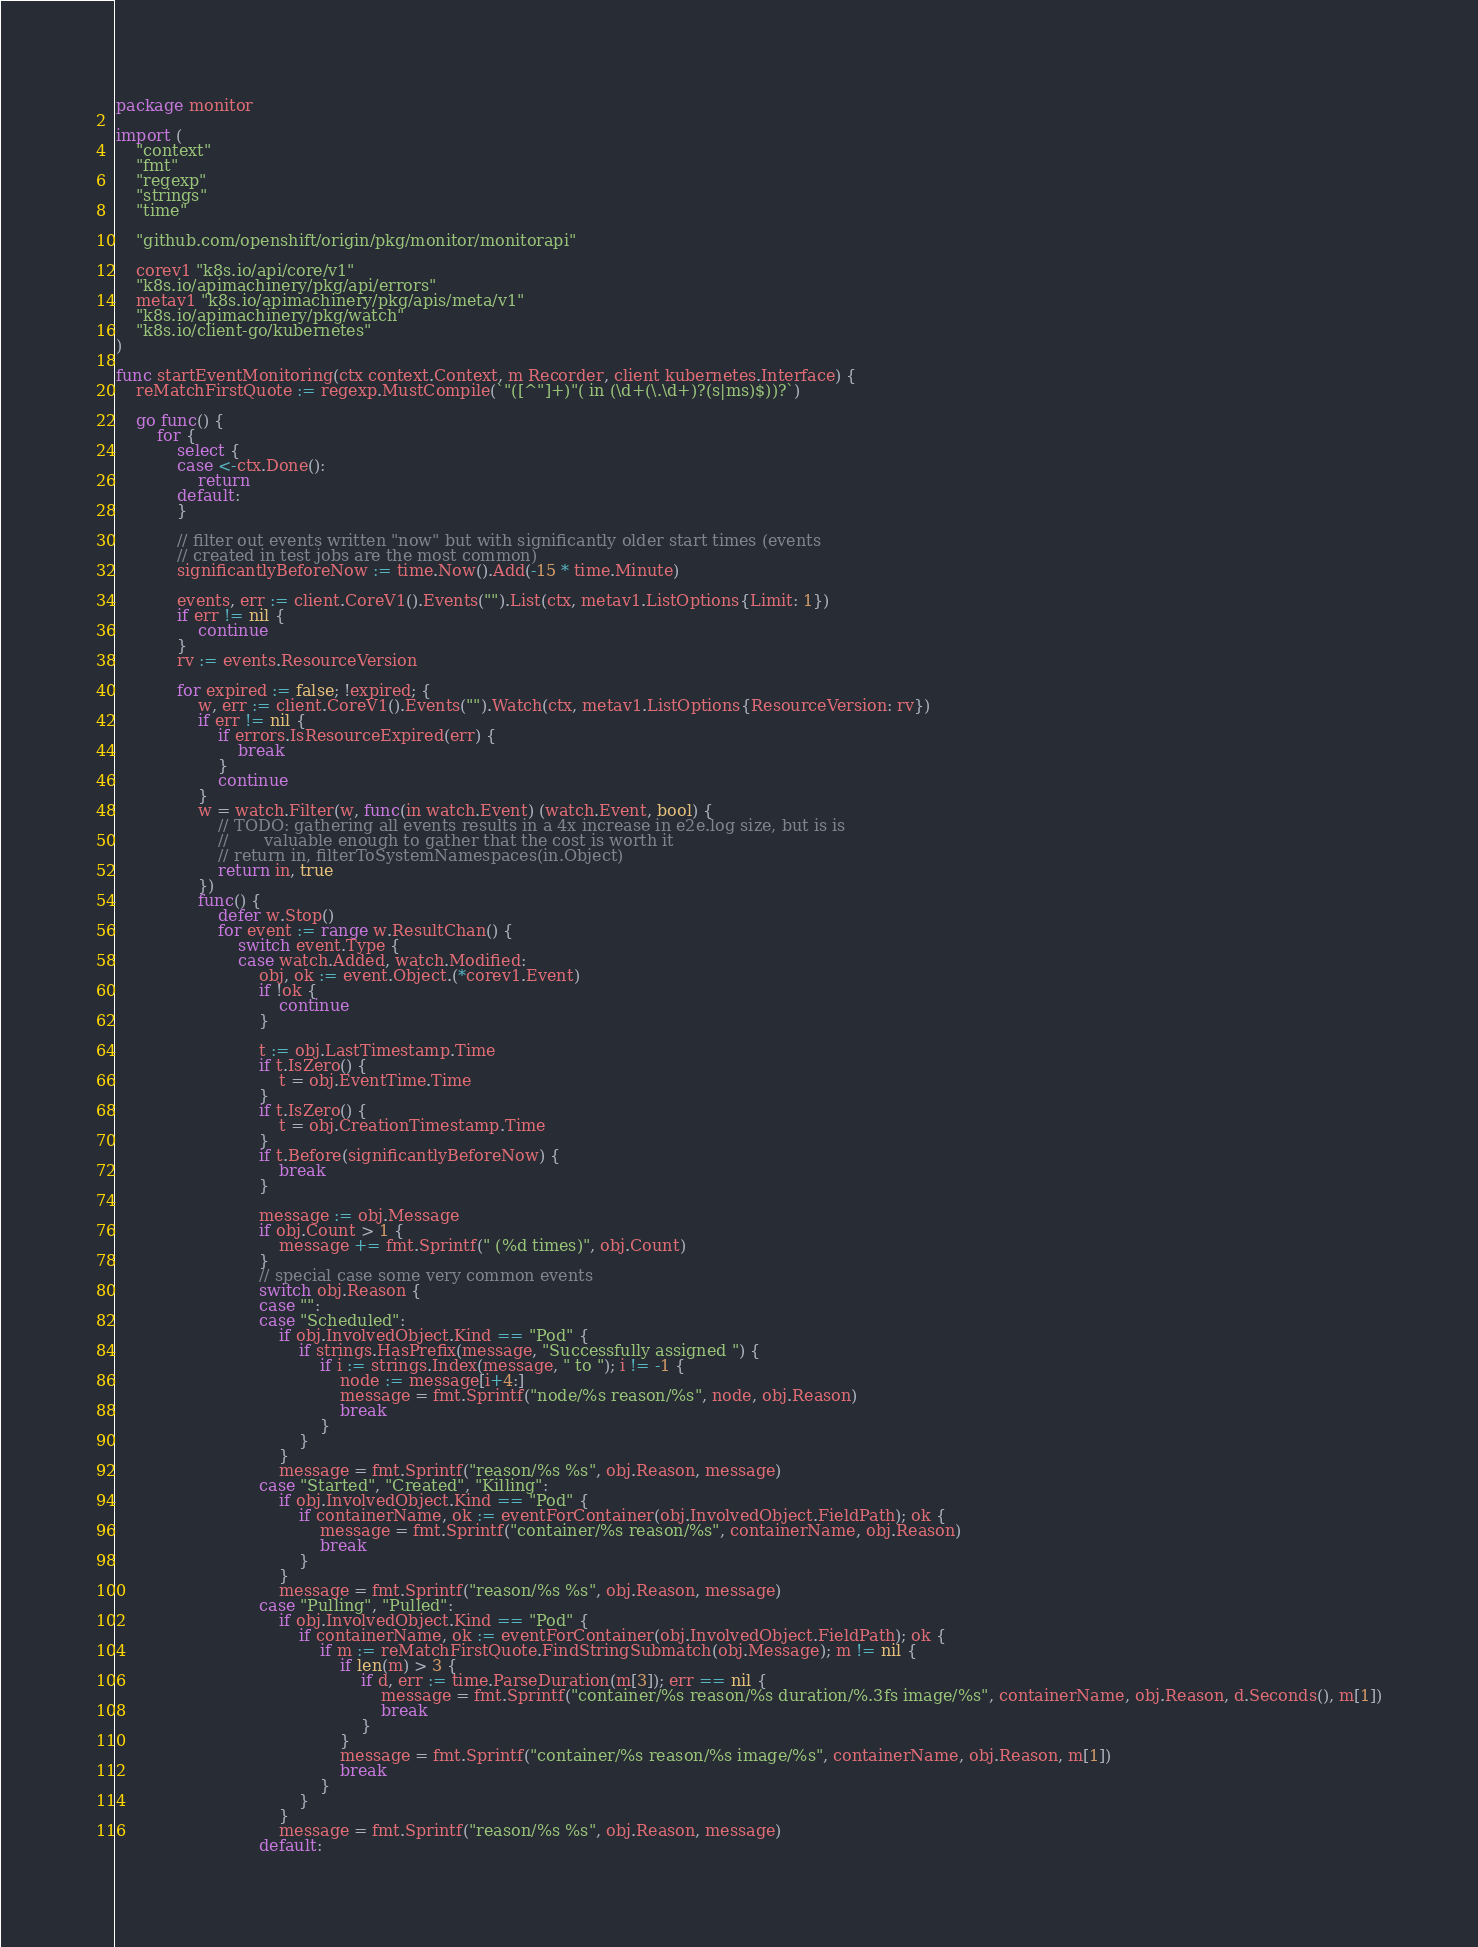Convert code to text. <code><loc_0><loc_0><loc_500><loc_500><_Go_>package monitor

import (
	"context"
	"fmt"
	"regexp"
	"strings"
	"time"

	"github.com/openshift/origin/pkg/monitor/monitorapi"

	corev1 "k8s.io/api/core/v1"
	"k8s.io/apimachinery/pkg/api/errors"
	metav1 "k8s.io/apimachinery/pkg/apis/meta/v1"
	"k8s.io/apimachinery/pkg/watch"
	"k8s.io/client-go/kubernetes"
)

func startEventMonitoring(ctx context.Context, m Recorder, client kubernetes.Interface) {
	reMatchFirstQuote := regexp.MustCompile(`"([^"]+)"( in (\d+(\.\d+)?(s|ms)$))?`)

	go func() {
		for {
			select {
			case <-ctx.Done():
				return
			default:
			}

			// filter out events written "now" but with significantly older start times (events
			// created in test jobs are the most common)
			significantlyBeforeNow := time.Now().Add(-15 * time.Minute)

			events, err := client.CoreV1().Events("").List(ctx, metav1.ListOptions{Limit: 1})
			if err != nil {
				continue
			}
			rv := events.ResourceVersion

			for expired := false; !expired; {
				w, err := client.CoreV1().Events("").Watch(ctx, metav1.ListOptions{ResourceVersion: rv})
				if err != nil {
					if errors.IsResourceExpired(err) {
						break
					}
					continue
				}
				w = watch.Filter(w, func(in watch.Event) (watch.Event, bool) {
					// TODO: gathering all events results in a 4x increase in e2e.log size, but is is
					//       valuable enough to gather that the cost is worth it
					// return in, filterToSystemNamespaces(in.Object)
					return in, true
				})
				func() {
					defer w.Stop()
					for event := range w.ResultChan() {
						switch event.Type {
						case watch.Added, watch.Modified:
							obj, ok := event.Object.(*corev1.Event)
							if !ok {
								continue
							}

							t := obj.LastTimestamp.Time
							if t.IsZero() {
								t = obj.EventTime.Time
							}
							if t.IsZero() {
								t = obj.CreationTimestamp.Time
							}
							if t.Before(significantlyBeforeNow) {
								break
							}

							message := obj.Message
							if obj.Count > 1 {
								message += fmt.Sprintf(" (%d times)", obj.Count)
							}
							// special case some very common events
							switch obj.Reason {
							case "":
							case "Scheduled":
								if obj.InvolvedObject.Kind == "Pod" {
									if strings.HasPrefix(message, "Successfully assigned ") {
										if i := strings.Index(message, " to "); i != -1 {
											node := message[i+4:]
											message = fmt.Sprintf("node/%s reason/%s", node, obj.Reason)
											break
										}
									}
								}
								message = fmt.Sprintf("reason/%s %s", obj.Reason, message)
							case "Started", "Created", "Killing":
								if obj.InvolvedObject.Kind == "Pod" {
									if containerName, ok := eventForContainer(obj.InvolvedObject.FieldPath); ok {
										message = fmt.Sprintf("container/%s reason/%s", containerName, obj.Reason)
										break
									}
								}
								message = fmt.Sprintf("reason/%s %s", obj.Reason, message)
							case "Pulling", "Pulled":
								if obj.InvolvedObject.Kind == "Pod" {
									if containerName, ok := eventForContainer(obj.InvolvedObject.FieldPath); ok {
										if m := reMatchFirstQuote.FindStringSubmatch(obj.Message); m != nil {
											if len(m) > 3 {
												if d, err := time.ParseDuration(m[3]); err == nil {
													message = fmt.Sprintf("container/%s reason/%s duration/%.3fs image/%s", containerName, obj.Reason, d.Seconds(), m[1])
													break
												}
											}
											message = fmt.Sprintf("container/%s reason/%s image/%s", containerName, obj.Reason, m[1])
											break
										}
									}
								}
								message = fmt.Sprintf("reason/%s %s", obj.Reason, message)
							default:</code> 